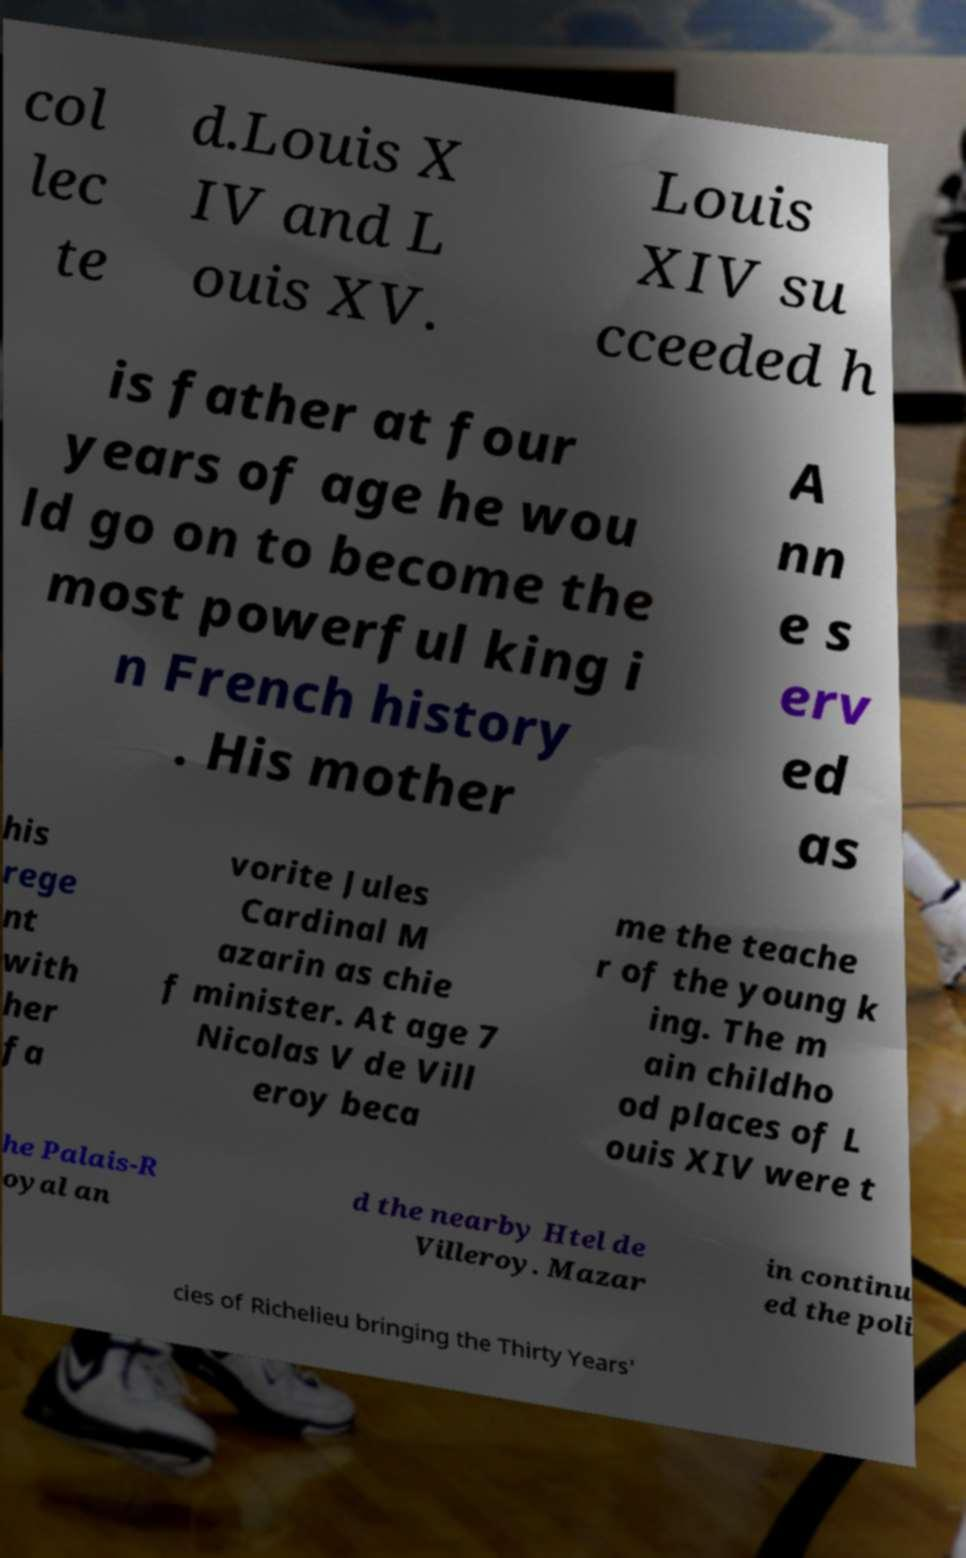Could you assist in decoding the text presented in this image and type it out clearly? col lec te d.Louis X IV and L ouis XV. Louis XIV su cceeded h is father at four years of age he wou ld go on to become the most powerful king i n French history . His mother A nn e s erv ed as his rege nt with her fa vorite Jules Cardinal M azarin as chie f minister. At age 7 Nicolas V de Vill eroy beca me the teache r of the young k ing. The m ain childho od places of L ouis XIV were t he Palais-R oyal an d the nearby Htel de Villeroy. Mazar in continu ed the poli cies of Richelieu bringing the Thirty Years' 